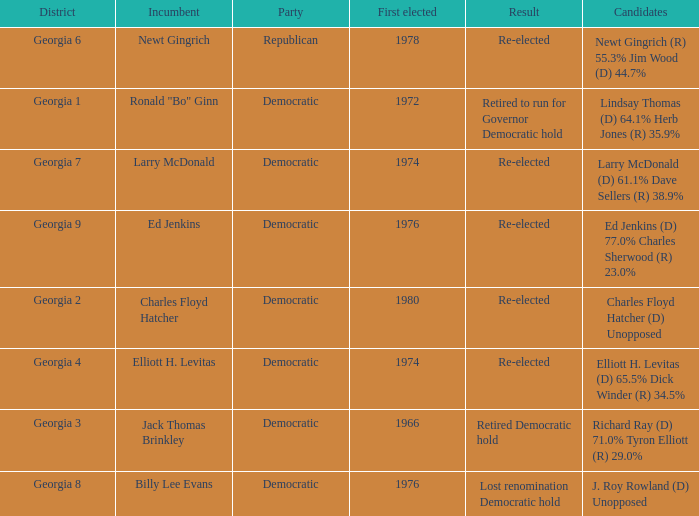Identify the district for larry mcdonald. Georgia 7. Would you be able to parse every entry in this table? {'header': ['District', 'Incumbent', 'Party', 'First elected', 'Result', 'Candidates'], 'rows': [['Georgia 6', 'Newt Gingrich', 'Republican', '1978', 'Re-elected', 'Newt Gingrich (R) 55.3% Jim Wood (D) 44.7%'], ['Georgia 1', 'Ronald "Bo" Ginn', 'Democratic', '1972', 'Retired to run for Governor Democratic hold', 'Lindsay Thomas (D) 64.1% Herb Jones (R) 35.9%'], ['Georgia 7', 'Larry McDonald', 'Democratic', '1974', 'Re-elected', 'Larry McDonald (D) 61.1% Dave Sellers (R) 38.9%'], ['Georgia 9', 'Ed Jenkins', 'Democratic', '1976', 'Re-elected', 'Ed Jenkins (D) 77.0% Charles Sherwood (R) 23.0%'], ['Georgia 2', 'Charles Floyd Hatcher', 'Democratic', '1980', 'Re-elected', 'Charles Floyd Hatcher (D) Unopposed'], ['Georgia 4', 'Elliott H. Levitas', 'Democratic', '1974', 'Re-elected', 'Elliott H. Levitas (D) 65.5% Dick Winder (R) 34.5%'], ['Georgia 3', 'Jack Thomas Brinkley', 'Democratic', '1966', 'Retired Democratic hold', 'Richard Ray (D) 71.0% Tyron Elliott (R) 29.0%'], ['Georgia 8', 'Billy Lee Evans', 'Democratic', '1976', 'Lost renomination Democratic hold', 'J. Roy Rowland (D) Unopposed']]} 